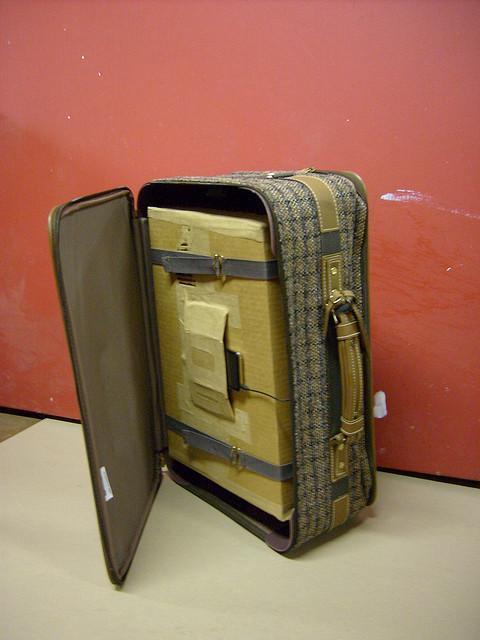How many ovens in this image have a window on their door?
Give a very brief answer. 0. 